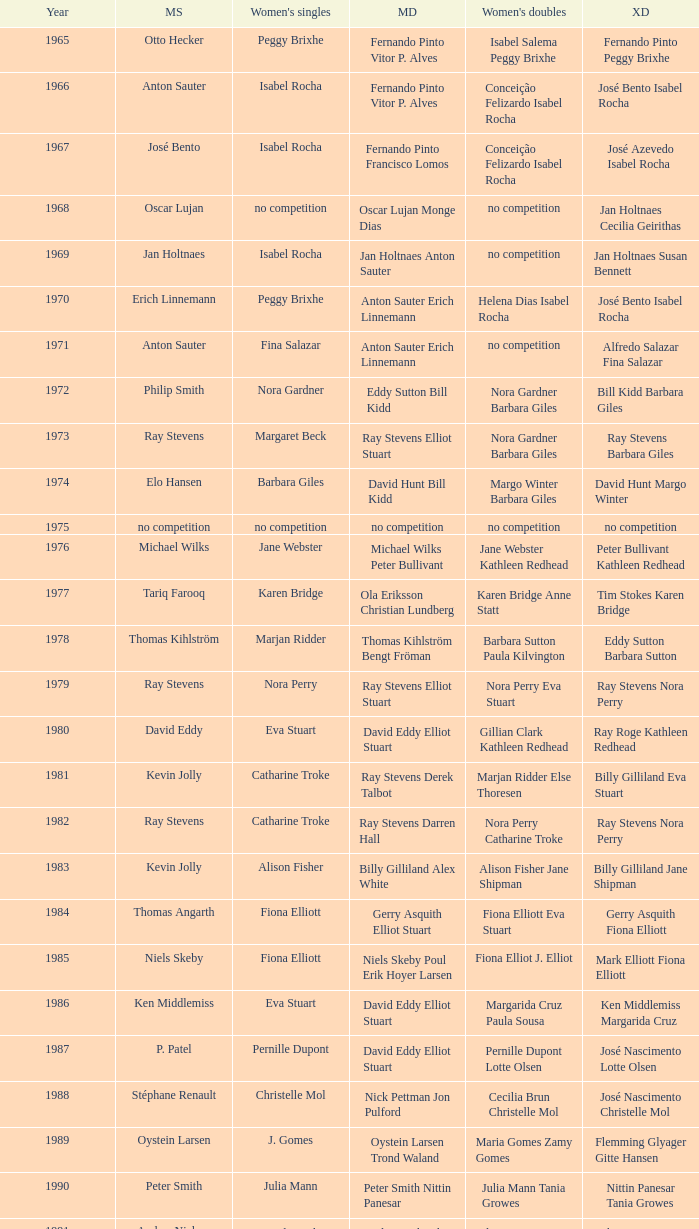What is the average year with alfredo salazar fina salazar in mixed doubles? 1971.0. Could you parse the entire table as a dict? {'header': ['Year', 'MS', "Women's singles", 'MD', "Women's doubles", 'XD'], 'rows': [['1965', 'Otto Hecker', 'Peggy Brixhe', 'Fernando Pinto Vitor P. Alves', 'Isabel Salema Peggy Brixhe', 'Fernando Pinto Peggy Brixhe'], ['1966', 'Anton Sauter', 'Isabel Rocha', 'Fernando Pinto Vitor P. Alves', 'Conceição Felizardo Isabel Rocha', 'José Bento Isabel Rocha'], ['1967', 'José Bento', 'Isabel Rocha', 'Fernando Pinto Francisco Lomos', 'Conceição Felizardo Isabel Rocha', 'José Azevedo Isabel Rocha'], ['1968', 'Oscar Lujan', 'no competition', 'Oscar Lujan Monge Dias', 'no competition', 'Jan Holtnaes Cecilia Geirithas'], ['1969', 'Jan Holtnaes', 'Isabel Rocha', 'Jan Holtnaes Anton Sauter', 'no competition', 'Jan Holtnaes Susan Bennett'], ['1970', 'Erich Linnemann', 'Peggy Brixhe', 'Anton Sauter Erich Linnemann', 'Helena Dias Isabel Rocha', 'José Bento Isabel Rocha'], ['1971', 'Anton Sauter', 'Fina Salazar', 'Anton Sauter Erich Linnemann', 'no competition', 'Alfredo Salazar Fina Salazar'], ['1972', 'Philip Smith', 'Nora Gardner', 'Eddy Sutton Bill Kidd', 'Nora Gardner Barbara Giles', 'Bill Kidd Barbara Giles'], ['1973', 'Ray Stevens', 'Margaret Beck', 'Ray Stevens Elliot Stuart', 'Nora Gardner Barbara Giles', 'Ray Stevens Barbara Giles'], ['1974', 'Elo Hansen', 'Barbara Giles', 'David Hunt Bill Kidd', 'Margo Winter Barbara Giles', 'David Hunt Margo Winter'], ['1975', 'no competition', 'no competition', 'no competition', 'no competition', 'no competition'], ['1976', 'Michael Wilks', 'Jane Webster', 'Michael Wilks Peter Bullivant', 'Jane Webster Kathleen Redhead', 'Peter Bullivant Kathleen Redhead'], ['1977', 'Tariq Farooq', 'Karen Bridge', 'Ola Eriksson Christian Lundberg', 'Karen Bridge Anne Statt', 'Tim Stokes Karen Bridge'], ['1978', 'Thomas Kihlström', 'Marjan Ridder', 'Thomas Kihlström Bengt Fröman', 'Barbara Sutton Paula Kilvington', 'Eddy Sutton Barbara Sutton'], ['1979', 'Ray Stevens', 'Nora Perry', 'Ray Stevens Elliot Stuart', 'Nora Perry Eva Stuart', 'Ray Stevens Nora Perry'], ['1980', 'David Eddy', 'Eva Stuart', 'David Eddy Elliot Stuart', 'Gillian Clark Kathleen Redhead', 'Ray Roge Kathleen Redhead'], ['1981', 'Kevin Jolly', 'Catharine Troke', 'Ray Stevens Derek Talbot', 'Marjan Ridder Else Thoresen', 'Billy Gilliland Eva Stuart'], ['1982', 'Ray Stevens', 'Catharine Troke', 'Ray Stevens Darren Hall', 'Nora Perry Catharine Troke', 'Ray Stevens Nora Perry'], ['1983', 'Kevin Jolly', 'Alison Fisher', 'Billy Gilliland Alex White', 'Alison Fisher Jane Shipman', 'Billy Gilliland Jane Shipman'], ['1984', 'Thomas Angarth', 'Fiona Elliott', 'Gerry Asquith Elliot Stuart', 'Fiona Elliott Eva Stuart', 'Gerry Asquith Fiona Elliott'], ['1985', 'Niels Skeby', 'Fiona Elliott', 'Niels Skeby Poul Erik Hoyer Larsen', 'Fiona Elliot J. Elliot', 'Mark Elliott Fiona Elliott'], ['1986', 'Ken Middlemiss', 'Eva Stuart', 'David Eddy Elliot Stuart', 'Margarida Cruz Paula Sousa', 'Ken Middlemiss Margarida Cruz'], ['1987', 'P. Patel', 'Pernille Dupont', 'David Eddy Elliot Stuart', 'Pernille Dupont Lotte Olsen', 'José Nascimento Lotte Olsen'], ['1988', 'Stéphane Renault', 'Christelle Mol', 'Nick Pettman Jon Pulford', 'Cecilia Brun Christelle Mol', 'José Nascimento Christelle Mol'], ['1989', 'Oystein Larsen', 'J. Gomes', 'Oystein Larsen Trond Waland', 'Maria Gomes Zamy Gomes', 'Flemming Glyager Gitte Hansen'], ['1990', 'Peter Smith', 'Julia Mann', 'Peter Smith Nittin Panesar', 'Julia Mann Tania Growes', 'Nittin Panesar Tania Growes'], ['1991', 'Anders Nielsen', 'Astrid van der Knaap', 'Andy Goode Glen Milton', 'Elena Denisova Marina Yakusheva', 'Chris Hunt Tracy Dineen'], ['1992', 'Andrey Antropov', 'Elena Rybkina', 'Andy Goode Chris Hunt', 'Joanne Wright Joanne Davies', 'Andy Goode Joanne Wright'], ['1993', 'Andrey Antropov', 'Marina Andrievskaia', 'Chan Kin Ngai Wong Wai Lap', 'Marina Andrievskaja Irina Yakusheva', 'Nikolaj Zuev Marina Yakusheva'], ['1994', 'Martin Lundgaard Hansen', 'Irina Yakusheva', 'Thomas Damgaard Jan Jörgensen', 'Rikke Olsen Helene Kirkegaard', 'Martin Lundgaard Hansen Rikke Olsen'], ['1995', 'Martin Lundgaard Hansen', 'Anne Sondergaard', 'Hendrik Sörensen Martin Lundgaard Hansen', 'Majken Vange Mette Hansen', 'Peder Nissen Mette Hansen'], ['1996', 'Rikard Magnusson', 'Karolina Ericsson', 'Ian Pearson James Anderson', 'Emma Chaffin Tracy Hallam', 'Nathan Robertson Gail Emms'], ['1997', 'Peter Janum', 'Ann Gibson', 'Fernando Silva Hugo Rodrigues', 'Karen Peatfield Tracy Hallam', 'Russel Hogg Alexis Blanchflower'], ['1998', 'Niels Christian Kaldau', 'Tanya Woodward', 'James Anderson Ian Pearson', 'Tracy Dineen Sarah Hardaker', 'Ian Sydie Denyse Julien'], ['1999', 'Peter Janum', 'Ella Karachkova', 'Manuel Dubrulle Vicent Laigle', 'Sara Sankey Ella Miles', 'Björn Siegemund Karen Stechmann'], ['2000', 'Rikard Magnusson', 'Elena Nozdran', 'Janek Roos Joachim Fischer Nielsen', 'Lene Mork Britta Andersen', 'Mathias Boe Karina Sørensen'], ['2001', 'Oliver Pongratz', 'Pi Hongyan', 'Michael Keck Joachim Tesche', 'Ella Miles Sarah Sankey', 'Björn Siegemund Nicol Pitro'], ['2002', 'Niels Christian Kaldau', 'Julia Mann', 'Michael Logosz Robert Mateusiak', 'Lene Mork Christiansen Helle Nielsen', 'Frederik Bergström Jenny Karlsson'], ['2003', 'Niels Christian Kaldau', 'Pi Hongyan', 'Jim Laugesen Michael Søgaard', 'Julie Houmann Helle Nielsen', 'Fredrik Bergström Johanna Persson'], ['2004', 'Stanislav Pukhov', 'Tracey Hallam', 'Simon Archer Robert Blair', 'Nadieżda Kostiuczyk Kamila Augustyn', 'Simon Archer Donna Kellogg'], ['2005', 'Arif Rasidi', 'Yuan Wemyss', 'Anthony Clark Simon Archer', 'Sandra Marinello Katrin Piotrowski', 'Simon Archer Donna Kellogg'], ['2006', 'Michael Christensen', 'Yuan Wemyss', 'Anders Kristiansen Simon Mollyhus', 'Liza Parker Jenny Day', 'Rasmus M. Andersen Mie Schjott-Kristensen'], ['2007', 'Peter Mikkelsen', 'Judith Meulendijks', 'Mikkel Delbo Larsen Jacob Chemnitz', 'Jenny Wallwork Suzanne Rayappan', 'Rasmus Bonde Christinna Pedersen'], ['2008', 'Anand Pawar', 'Kaori Imabeppu', 'Ruud Bosch Koen Ridder', 'Cai Jiani Zhang Xi', 'Zhang Yi Cai Jiani'], ['2009', 'Magnus Sahlberg', 'Jill Pittard', 'Ruben Gordown Stenny Kusuma', 'Emelie Lennartsson Emma Wengberg', 'Lukasz Moren Natalia Pocztowiak'], ['2010', 'Kenn Lim', 'Telma Santos', 'Martin Kragh Anders Skaarup Rasmussen', 'Lauren Smith Alexandra Langley', 'Zvonimir Durkinjak Stasa Poznanovic'], ['2011', 'Sven-Eric Kastens', 'Sashina Vignes Waran', 'Niclas Nohr Mads Pedersen', 'Lauren Smith Alexandra Langley', 'Robin Middleton Alexandra Langley'], ['2012', 'Dieter Domke', 'Beatriz Corrales', 'Zvonimir Durkinjak Nikolaj Overgaard', 'Gabrielle White Alexandra Langley', 'Marcus Ellis Gabrielle White'], ['2013', 'Ramdan Misbun', 'Ella Diehl', 'Anders Skaarup Rasmussen Kim Astrup Sorensen', 'Lena Grebak Maria Helsbol', 'Jones Rafli Jansen Keshya Nurvita Hanadia']]} 